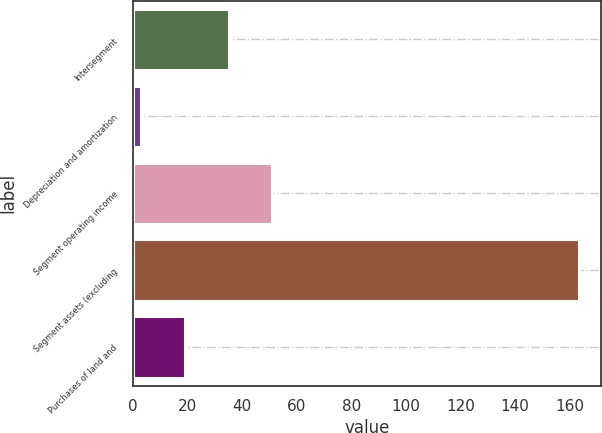Convert chart to OTSL. <chart><loc_0><loc_0><loc_500><loc_500><bar_chart><fcel>Intersegment<fcel>Depreciation and amortization<fcel>Segment operating income<fcel>Segment assets (excluding<fcel>Purchases of land and<nl><fcel>35.1<fcel>3<fcel>51.15<fcel>163.5<fcel>19.05<nl></chart> 